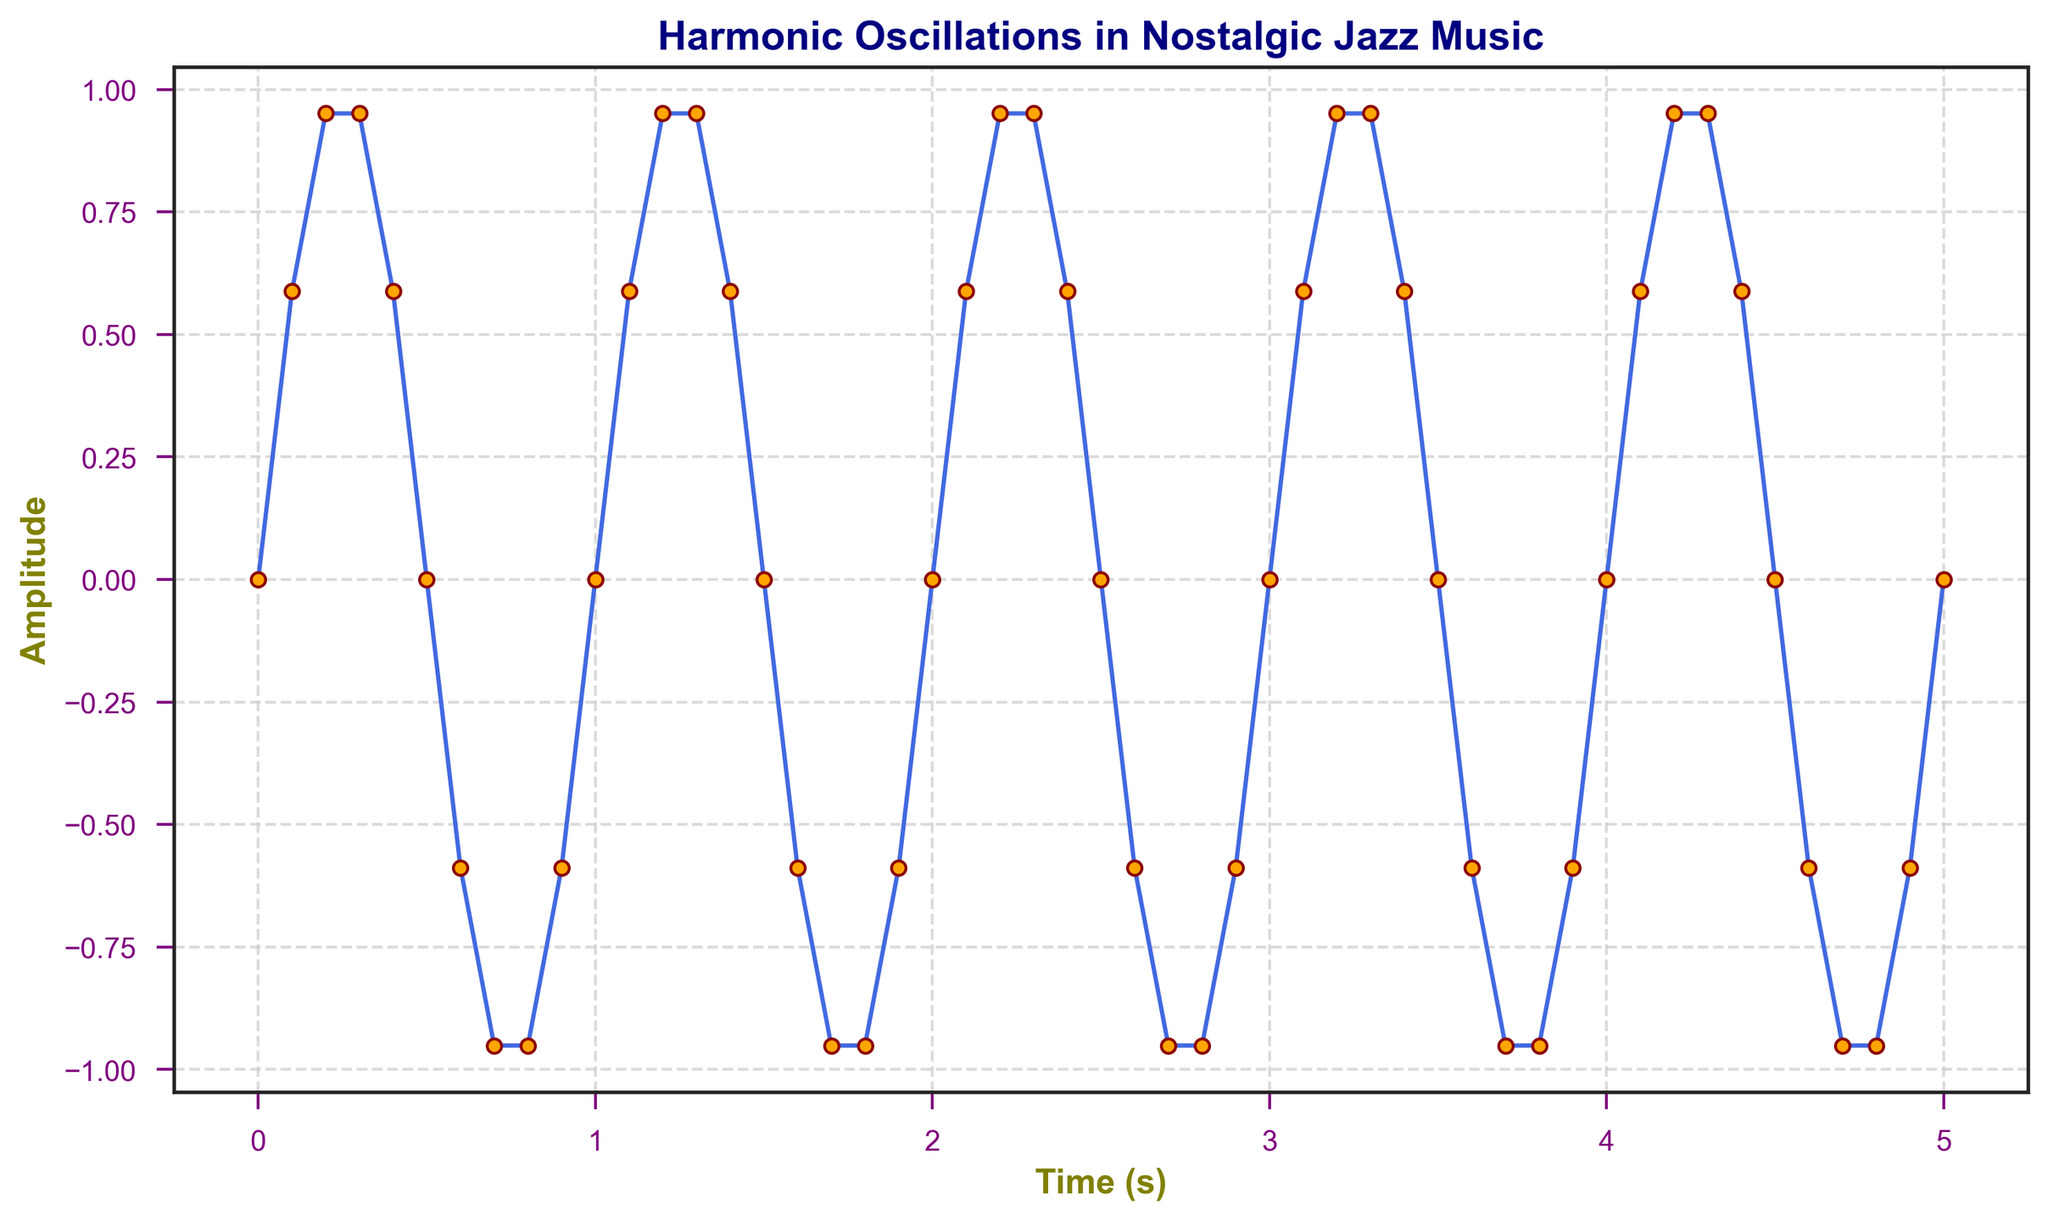What is the amplitude at time = 1s? Look at the value corresponding to time = 1 second. The amplitude shown on the graph at this point is approximately 0.
Answer: 0 At which time points does the amplitude reach its maximum? Identify where the amplitude peaks on the graph. These occur at 0.2s, 0.3s, 1.2s, 1.3s, 2.2s, 2.3s, and so on. These time points correspond to the amplitude values of approximately 0.951.
Answer: 0.2s, 0.3s, 1.2s, 1.3s, 2.2s, 2.3s, .. How many full oscillation cycles are observed within the 5-second interval? Each full oscillation cycle consists of a complete wave from peak to peak or trough to trough. Count the number of complete cycles within the time range from 0 to 5 seconds. The pattern repeats approximately every 2 seconds.
Answer: 2.5 cycles What is the period of the oscillation? The period is the time it takes for one full cycle of the wave. By observing the repeated pattern from peak to peak or trough to trough, the period can be seen to be approximately every 2 seconds.
Answer: 2 seconds How does the amplitude at time = 0.7s compare to that at time = 3.9s? Compare the y-values (amplitudes) at these two time points. At 0.7s, the amplitude is -0.951, and at 3.9s, it is also approximately -0.951. This denotes that the amplitudes at these time points are equal.
Answer: Equal Which marker color is used for the data points on the plot? Look at the color of the markers used for the data points in the plot. They are depicted in orange.
Answer: Orange What is the average amplitude over the first second? Calculate the average by summing the amplitudes at each time point within the first second (0, 0.1, 0.2, ..., 1.0) and dividing by the number of these points. Amplitudes: 0 + 0.587785 + 0.951057 + 0.951057 + 0.587785 + 0 = 3.077684. Number of points: 11. Average amplitude = 3.077684 / 11.
Answer: ≈ 0.279 By looking at the visual style, how would you describe the overall mood or feeling conveyed by the figure? The colors and design choices such as royal blue lines with orange markers on a clean seaborn-style background, combined with the smooth oscillations, evoke a sense of calm and nostalgia that complements the theme of nostalgic jazz music.
Answer: Calm and nostalgic Between time = 0.3s and 0.5s, what is the range of amplitudes? Identify the maximum and minimum amplitudes between these time points. The highest value is at 0.3s (0.951) and the lowest at 0.5s (approximately 0). The range is calculated as 0.951 - 0 = 0.951.
Answer: 0.951 